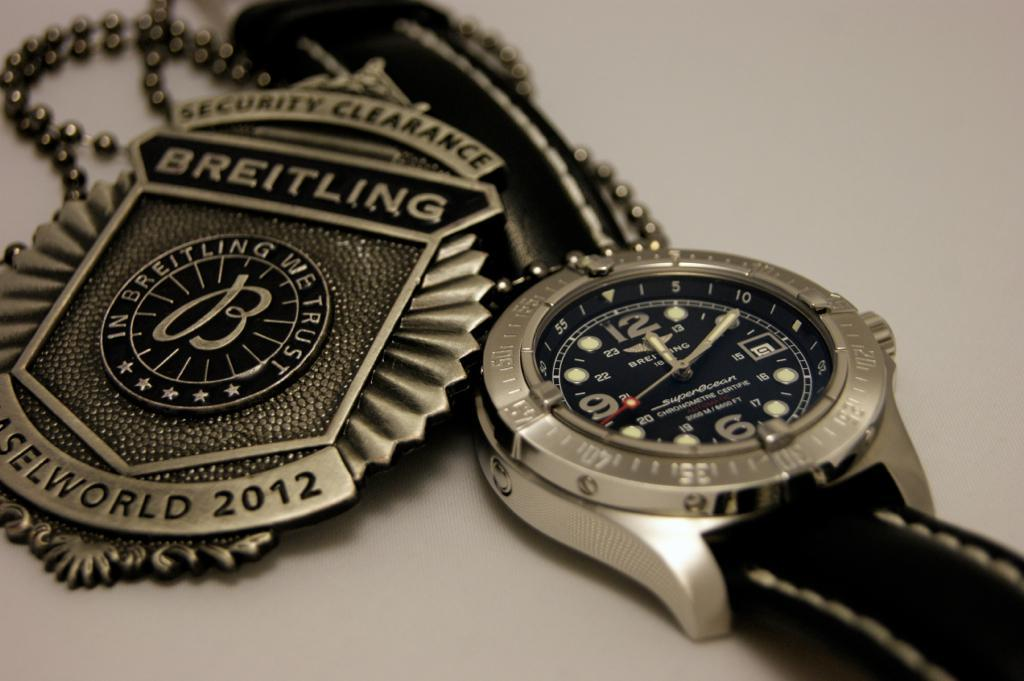<image>
Relay a brief, clear account of the picture shown. A watch on a table and a Security Clearance badge next to it. 